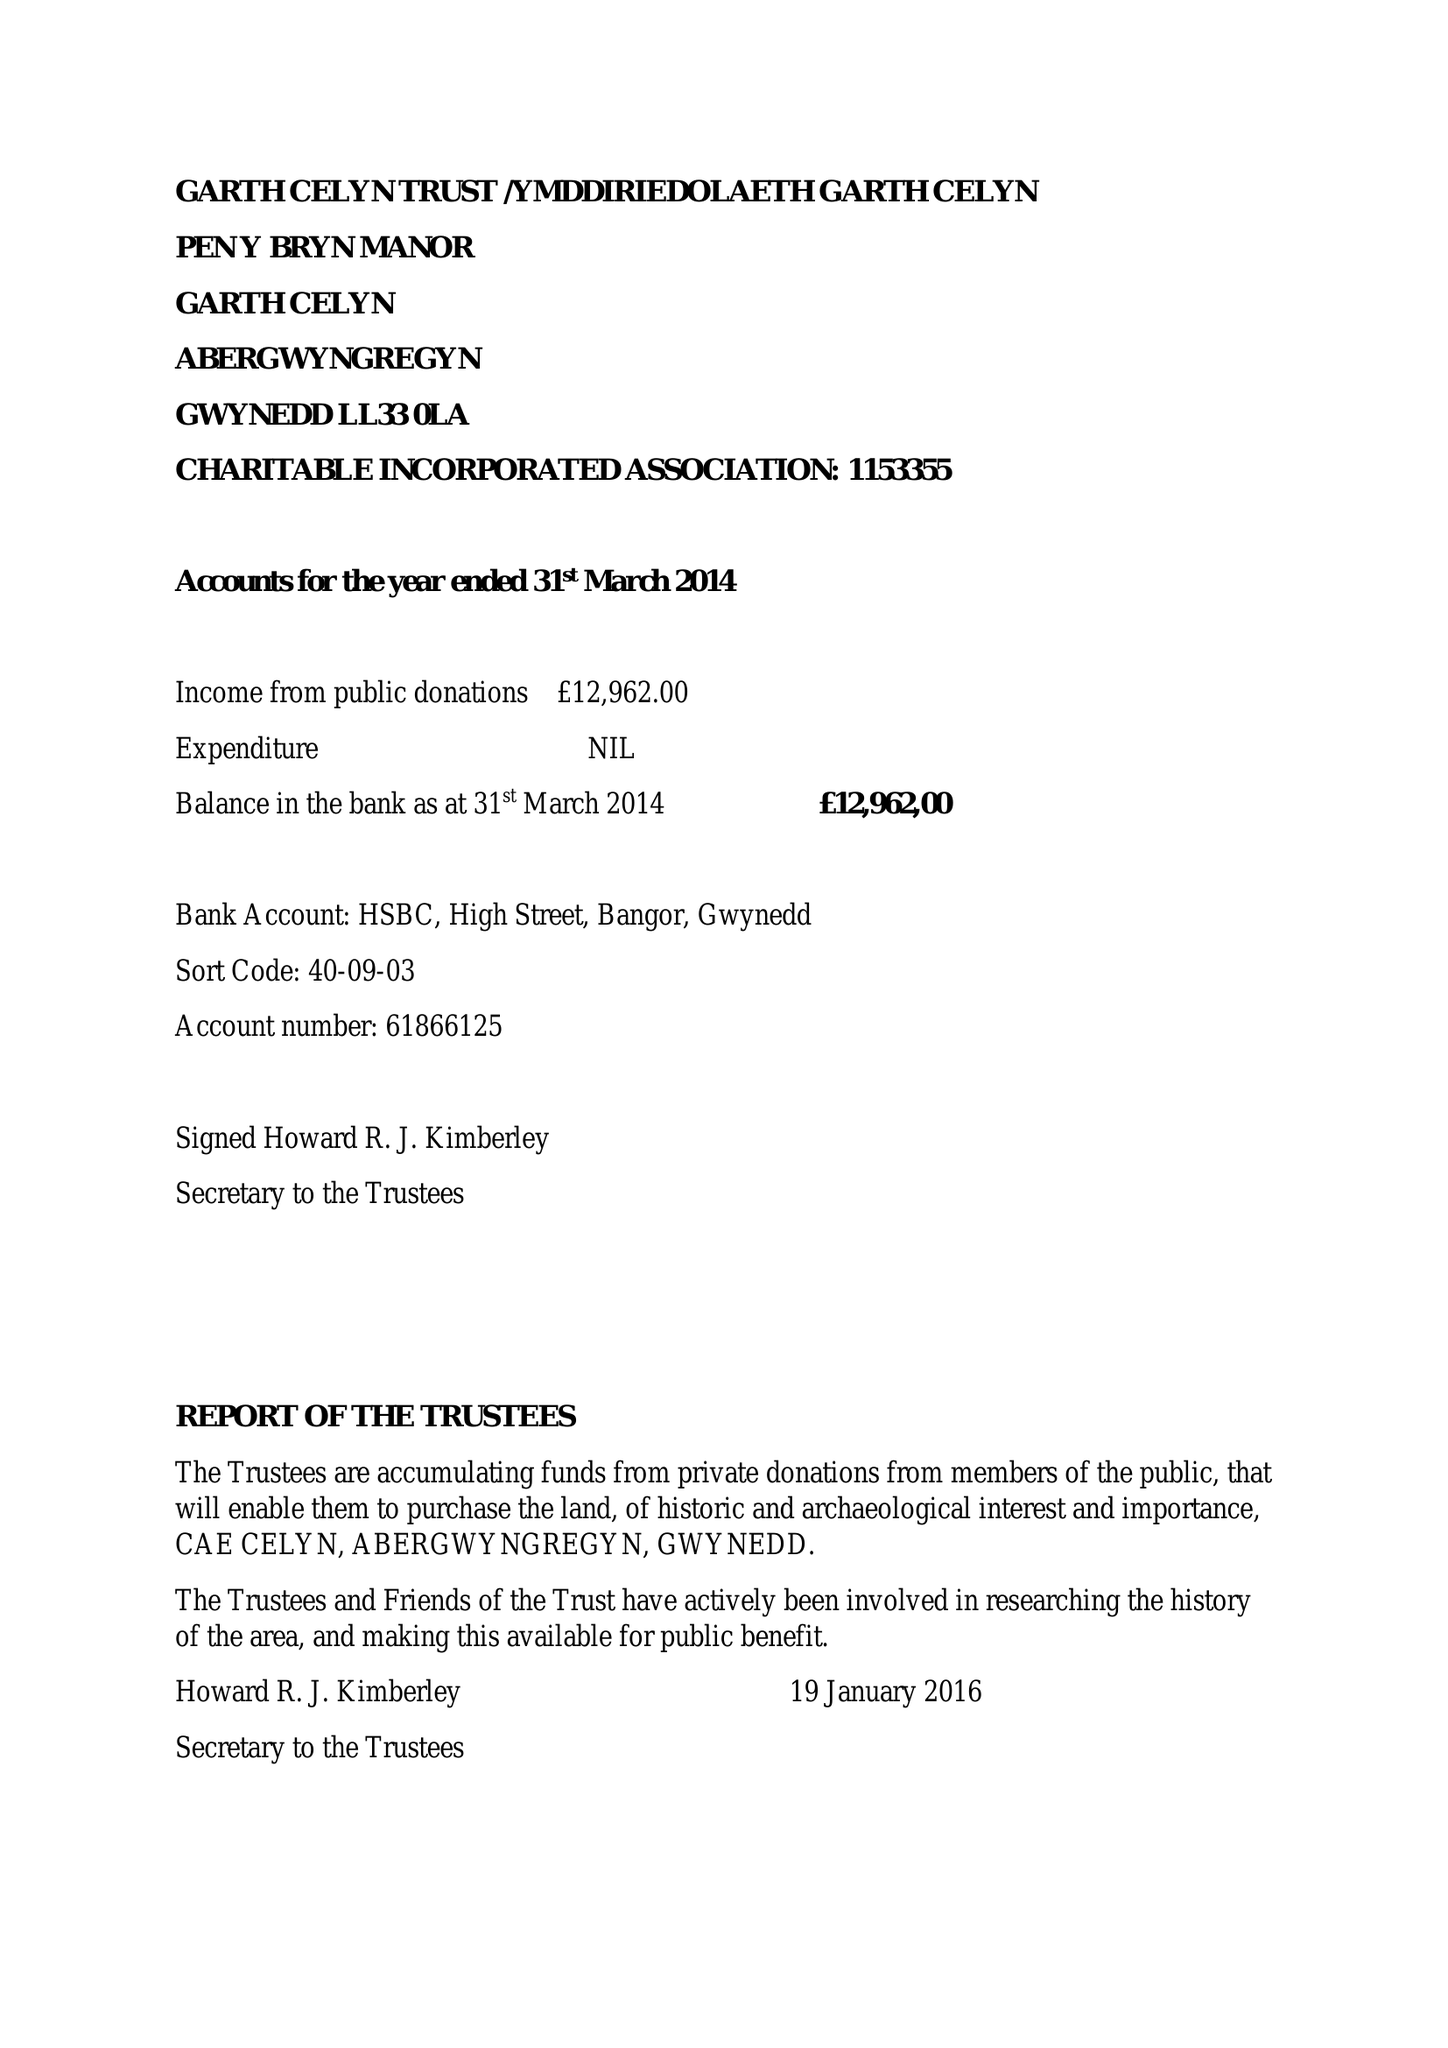What is the value for the address__street_line?
Answer the question using a single word or phrase. None 